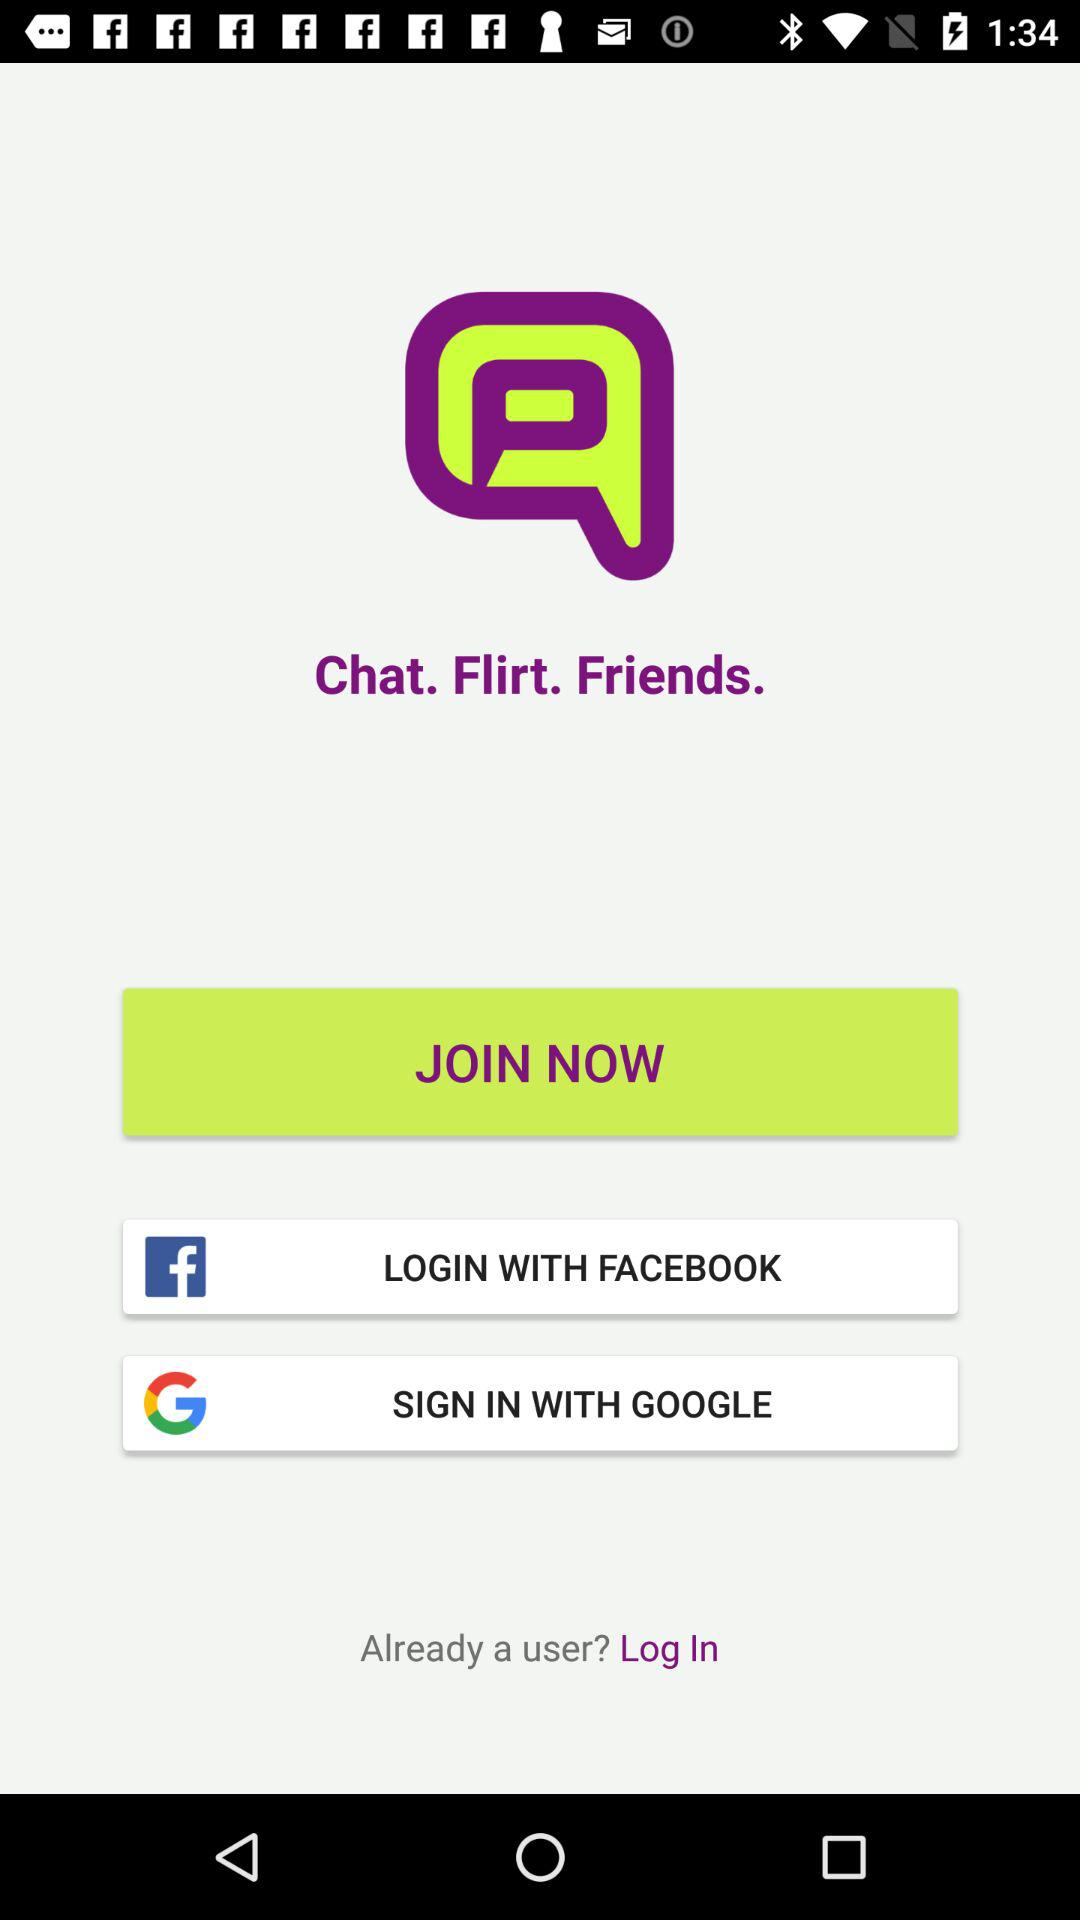What is the app name? The app name is "Chat. Flirt. Friends.". 